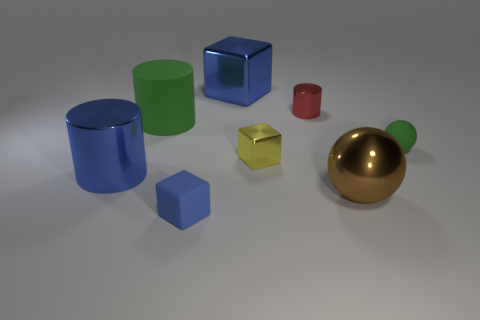Subtract all yellow cylinders. How many blue blocks are left? 2 Subtract all matte cylinders. How many cylinders are left? 2 Subtract 1 cylinders. How many cylinders are left? 2 Add 1 tiny gray shiny cylinders. How many objects exist? 9 Subtract all cubes. How many objects are left? 5 Add 8 big brown objects. How many big brown objects exist? 9 Subtract 0 yellow balls. How many objects are left? 8 Subtract all small red metallic cylinders. Subtract all yellow blocks. How many objects are left? 6 Add 8 brown balls. How many brown balls are left? 9 